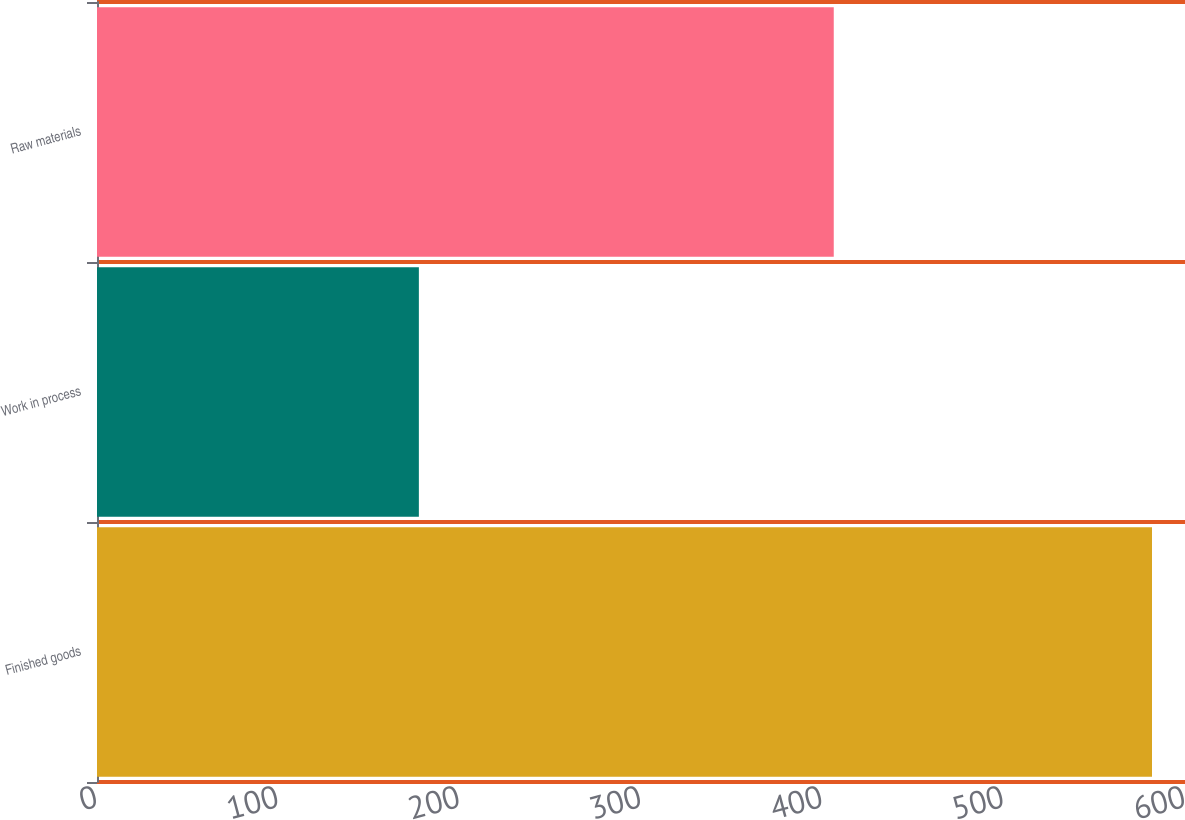<chart> <loc_0><loc_0><loc_500><loc_500><bar_chart><fcel>Finished goods<fcel>Work in process<fcel>Raw materials<nl><fcel>581.8<fcel>177.5<fcel>406.3<nl></chart> 